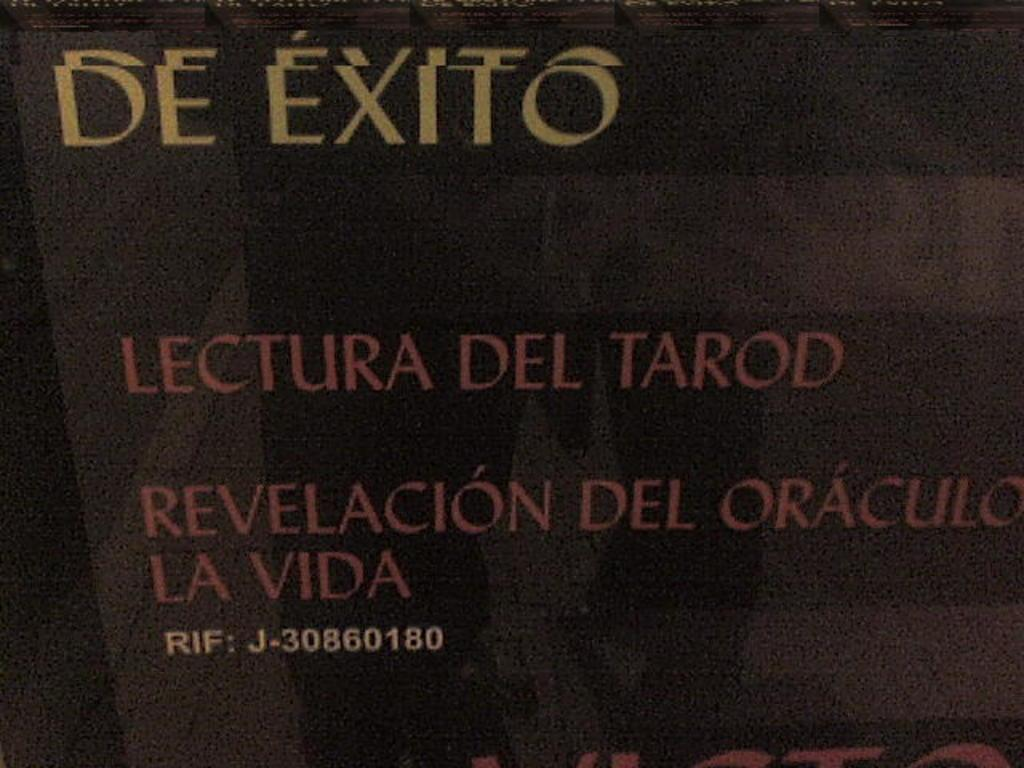Provide a one-sentence caption for the provided image. The words De Exito are written on a dark background with some other words in Spanish. 